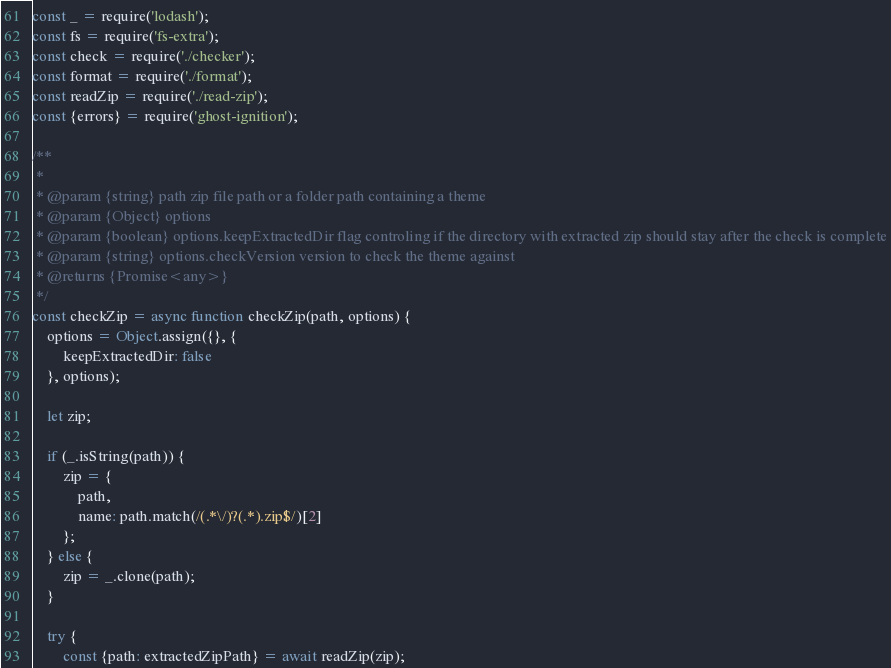Convert code to text. <code><loc_0><loc_0><loc_500><loc_500><_JavaScript_>const _ = require('lodash');
const fs = require('fs-extra');
const check = require('./checker');
const format = require('./format');
const readZip = require('./read-zip');
const {errors} = require('ghost-ignition');

/**
 *
 * @param {string} path zip file path or a folder path containing a theme
 * @param {Object} options
 * @param {boolean} options.keepExtractedDir flag controling if the directory with extracted zip should stay after the check is complete
 * @param {string} options.checkVersion version to check the theme against
 * @returns {Promise<any>}
 */
const checkZip = async function checkZip(path, options) {
    options = Object.assign({}, {
        keepExtractedDir: false
    }, options);

    let zip;

    if (_.isString(path)) {
        zip = {
            path,
            name: path.match(/(.*\/)?(.*).zip$/)[2]
        };
    } else {
        zip = _.clone(path);
    }

    try {
        const {path: extractedZipPath} = await readZip(zip);</code> 